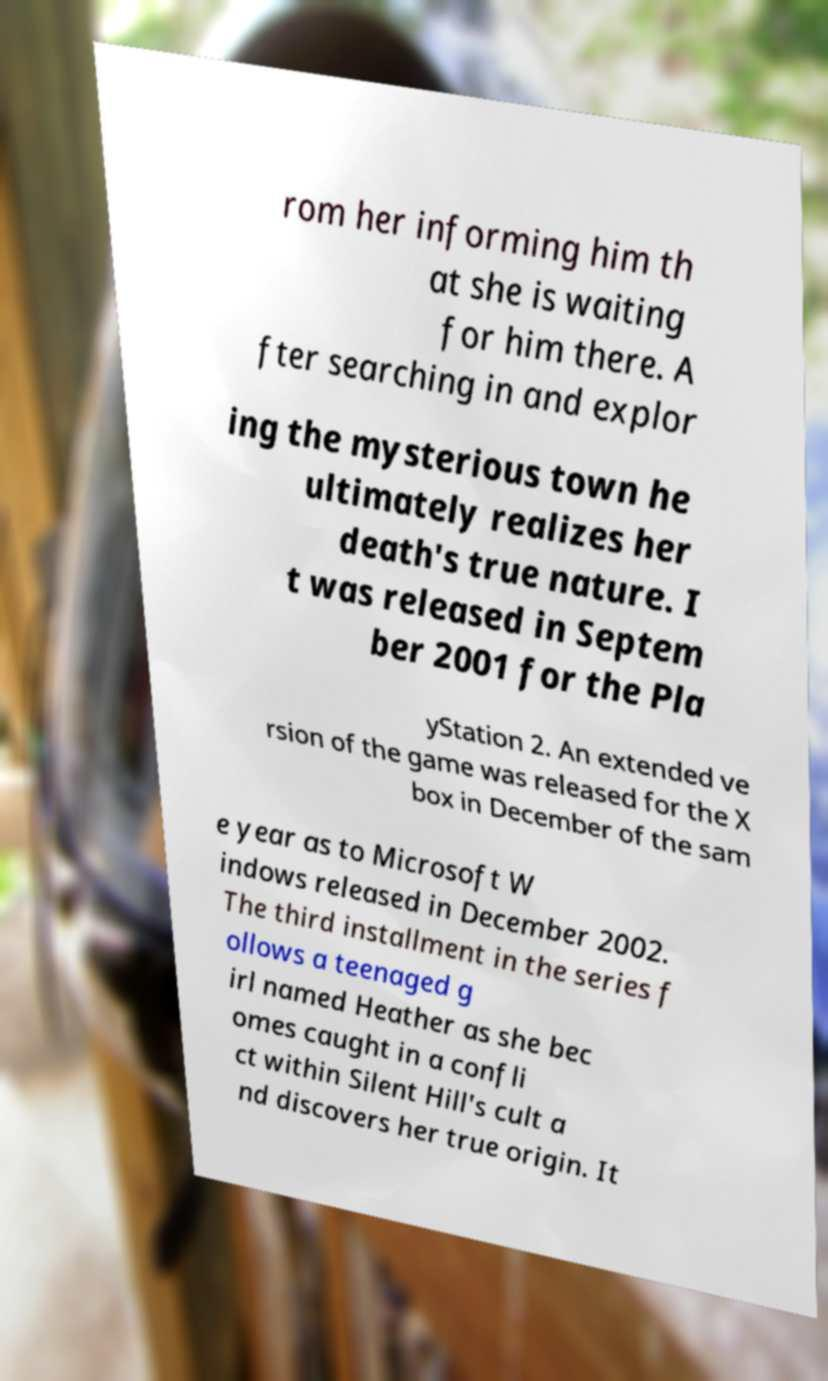Could you extract and type out the text from this image? rom her informing him th at she is waiting for him there. A fter searching in and explor ing the mysterious town he ultimately realizes her death's true nature. I t was released in Septem ber 2001 for the Pla yStation 2. An extended ve rsion of the game was released for the X box in December of the sam e year as to Microsoft W indows released in December 2002. The third installment in the series f ollows a teenaged g irl named Heather as she bec omes caught in a confli ct within Silent Hill's cult a nd discovers her true origin. It 